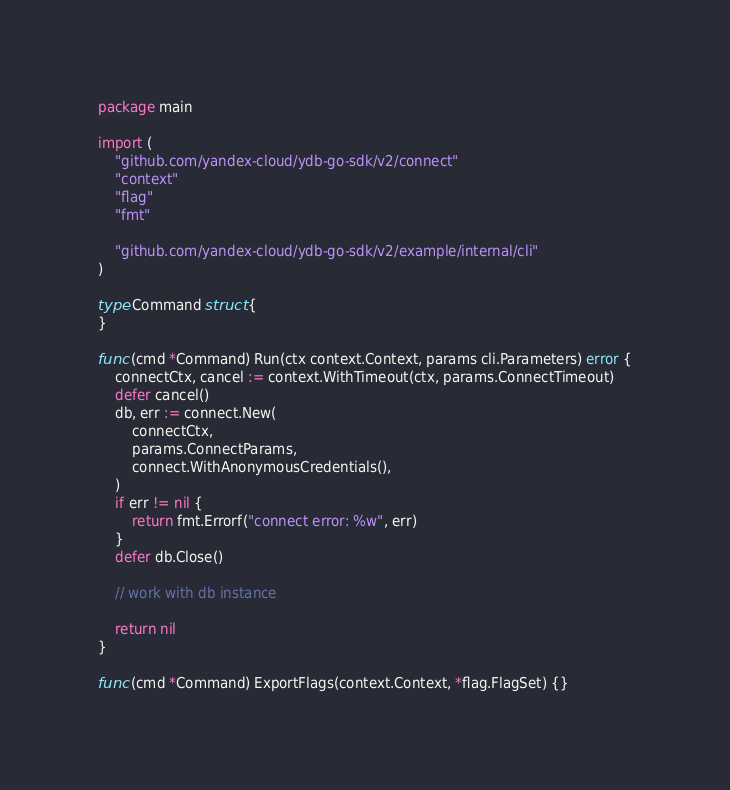Convert code to text. <code><loc_0><loc_0><loc_500><loc_500><_Go_>package main

import (
	"github.com/yandex-cloud/ydb-go-sdk/v2/connect"
	"context"
	"flag"
	"fmt"

	"github.com/yandex-cloud/ydb-go-sdk/v2/example/internal/cli"
)

type Command struct {
}

func (cmd *Command) Run(ctx context.Context, params cli.Parameters) error {
	connectCtx, cancel := context.WithTimeout(ctx, params.ConnectTimeout)
	defer cancel()
	db, err := connect.New(
		connectCtx,
		params.ConnectParams,
		connect.WithAnonymousCredentials(),
	)
	if err != nil {
		return fmt.Errorf("connect error: %w", err)
	}
	defer db.Close()

	// work with db instance

	return nil
}

func (cmd *Command) ExportFlags(context.Context, *flag.FlagSet) {}
</code> 